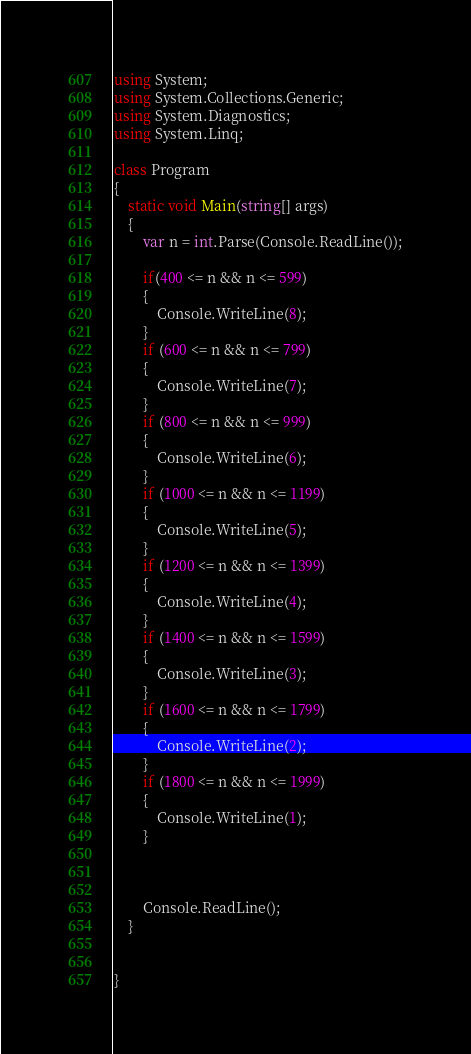Convert code to text. <code><loc_0><loc_0><loc_500><loc_500><_C#_>using System;
using System.Collections.Generic;
using System.Diagnostics;
using System.Linq;

class Program
{
    static void Main(string[] args)
    {
        var n = int.Parse(Console.ReadLine());

        if(400 <= n && n <= 599)
        {
            Console.WriteLine(8);
        }
        if (600 <= n && n <= 799)
        {
            Console.WriteLine(7);
        }
        if (800 <= n && n <= 999)
        {
            Console.WriteLine(6);
        }
        if (1000 <= n && n <= 1199)
        {
            Console.WriteLine(5);
        }
        if (1200 <= n && n <= 1399)
        {
            Console.WriteLine(4);
        }
        if (1400 <= n && n <= 1599)
        {
            Console.WriteLine(3);
        }
        if (1600 <= n && n <= 1799)
        {
            Console.WriteLine(2);
        }
        if (1800 <= n && n <= 1999)
        {
            Console.WriteLine(1);
        }



        Console.ReadLine();
    }


}


</code> 